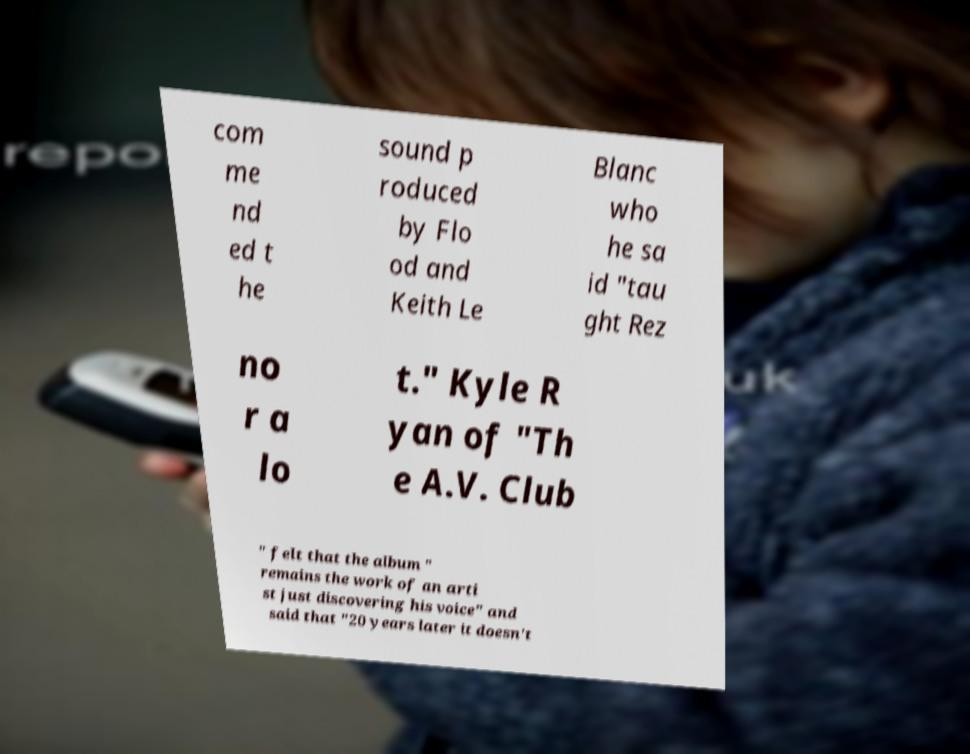What messages or text are displayed in this image? I need them in a readable, typed format. com me nd ed t he sound p roduced by Flo od and Keith Le Blanc who he sa id "tau ght Rez no r a lo t." Kyle R yan of "Th e A.V. Club " felt that the album " remains the work of an arti st just discovering his voice" and said that "20 years later it doesn't 